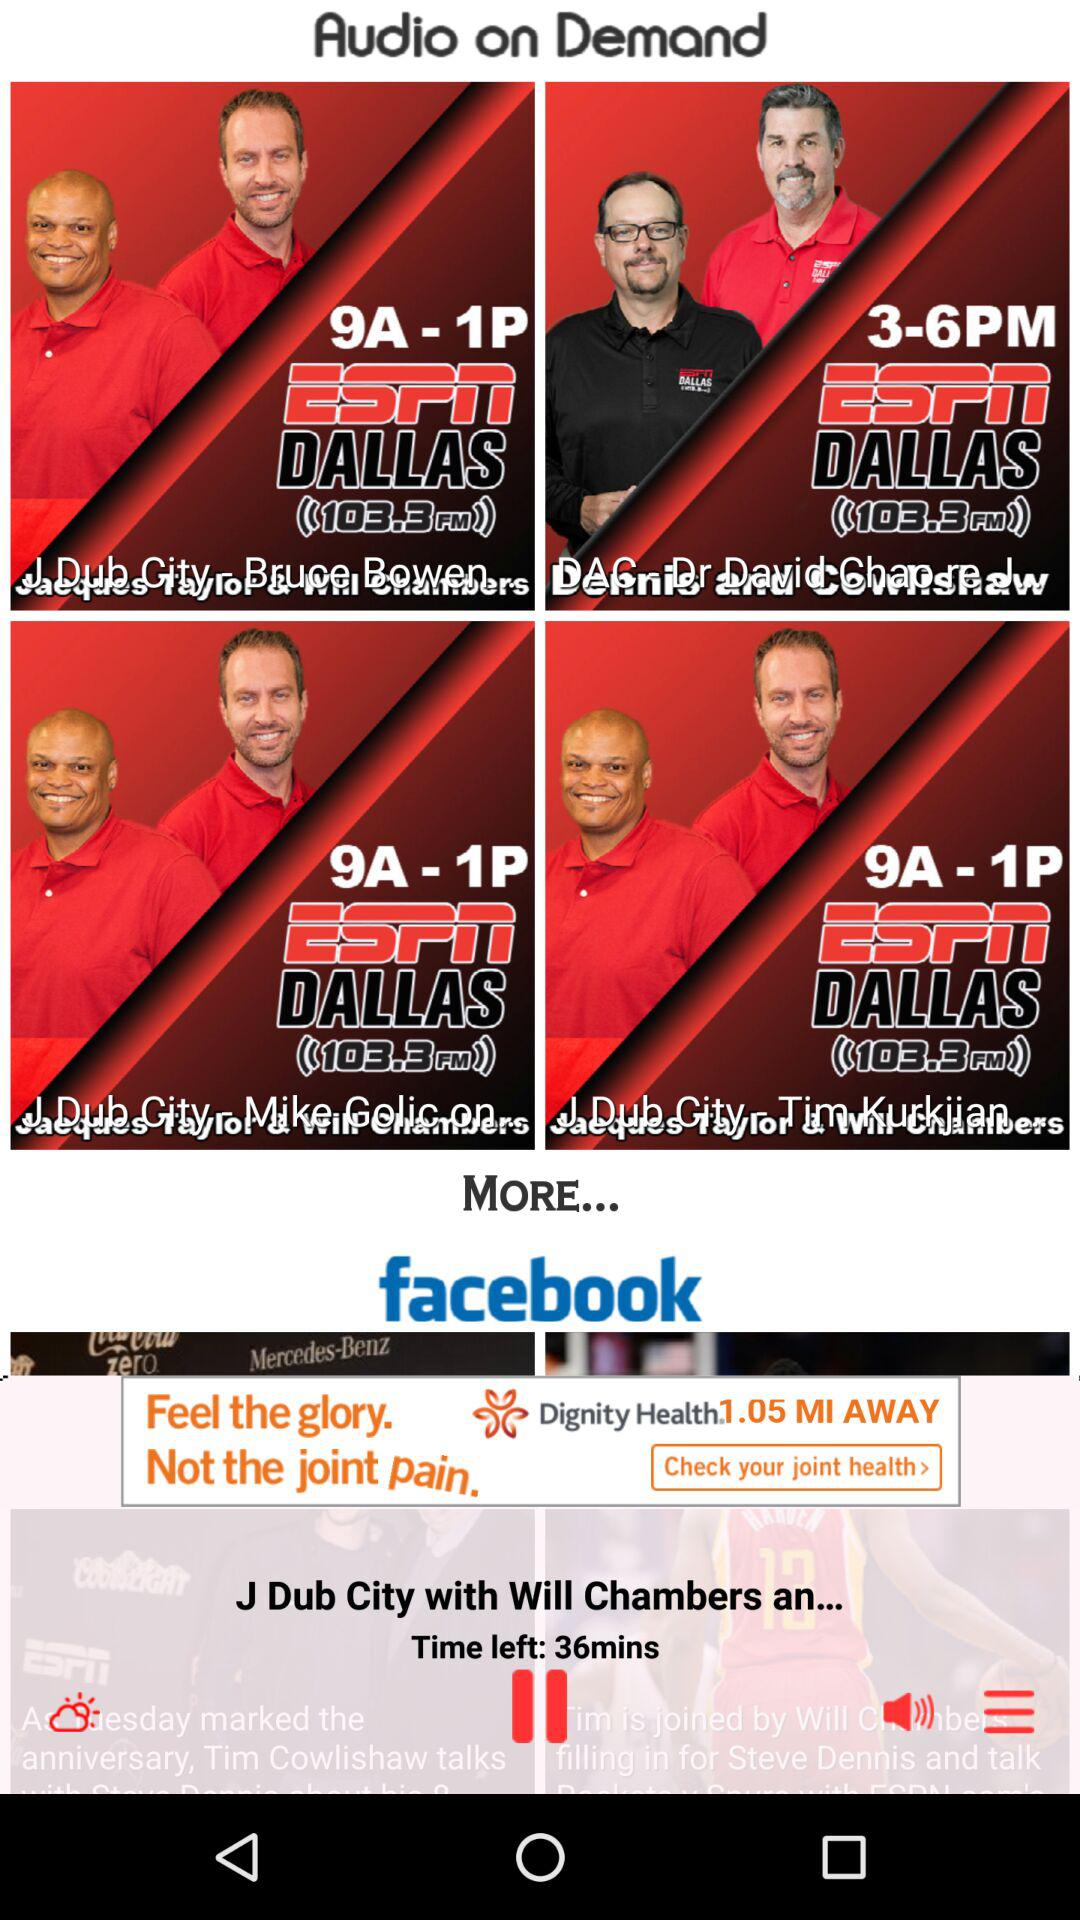Which track is currently playing? The currently playing track is "J Dub City with Will Chambers an...". 